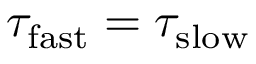<formula> <loc_0><loc_0><loc_500><loc_500>\tau _ { f a s t } = \tau _ { s l o w }</formula> 